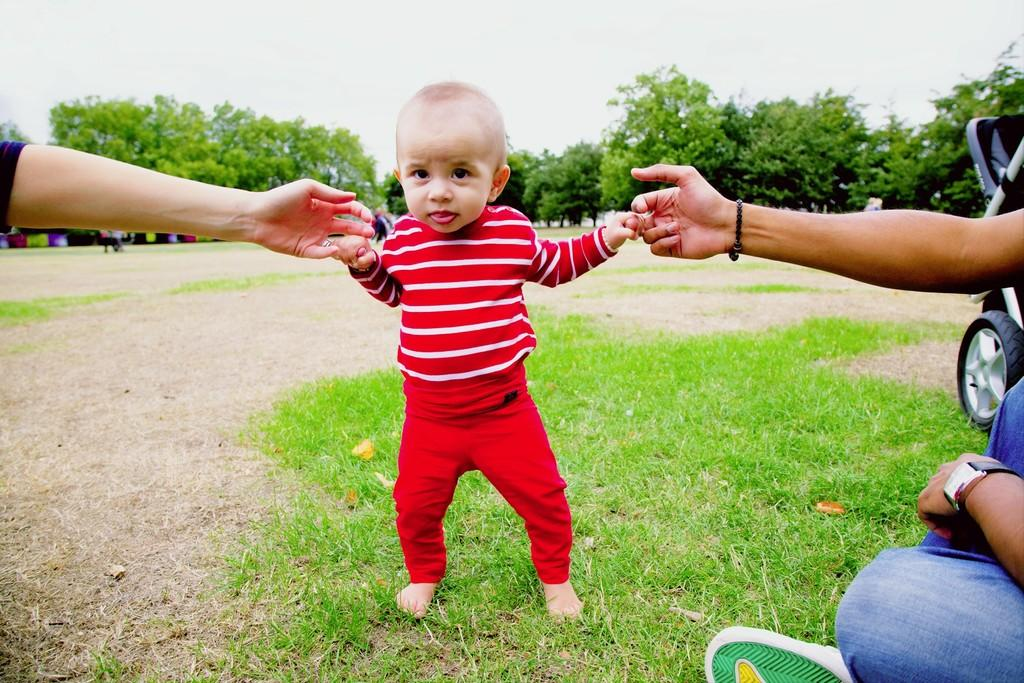How many people are in the image? There are three persons in the image. Where are the persons located in the image? The persons are on the grass. What else can be seen in the image besides the people? There are vehicles and trees in the image. What is visible in the background of the image? The sky is visible in the background of the image. Can you describe the setting of the image? The image appears to be taken in a park during the day. What is the income of the person holding the milk in the image? There is no person holding milk in the image, and therefore no income can be determined. 